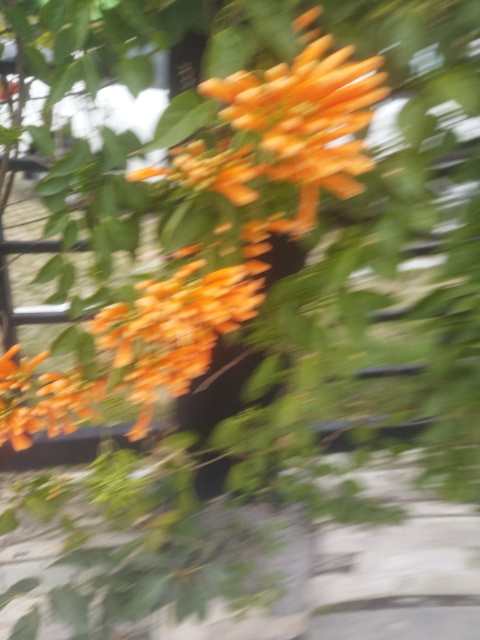Are the details in the photo clear? No, the details in the photo are not clear as the image is blurry, making it difficult to discern the finer details of the flowers and foliage. Improving focus or using a higher resolution could help capture the intricate details more clearly. 